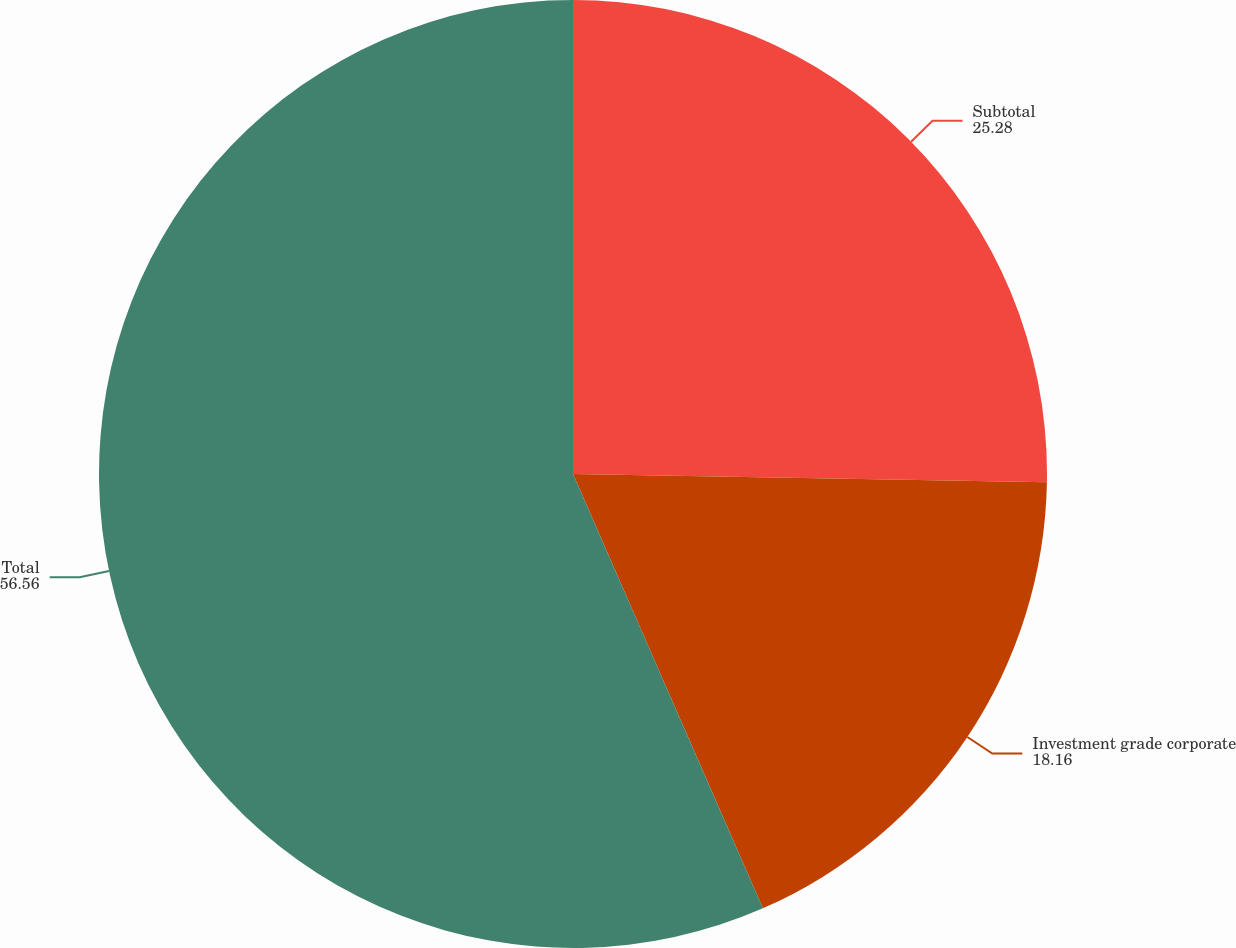<chart> <loc_0><loc_0><loc_500><loc_500><pie_chart><fcel>Subtotal<fcel>Investment grade corporate<fcel>Total<nl><fcel>25.28%<fcel>18.16%<fcel>56.56%<nl></chart> 